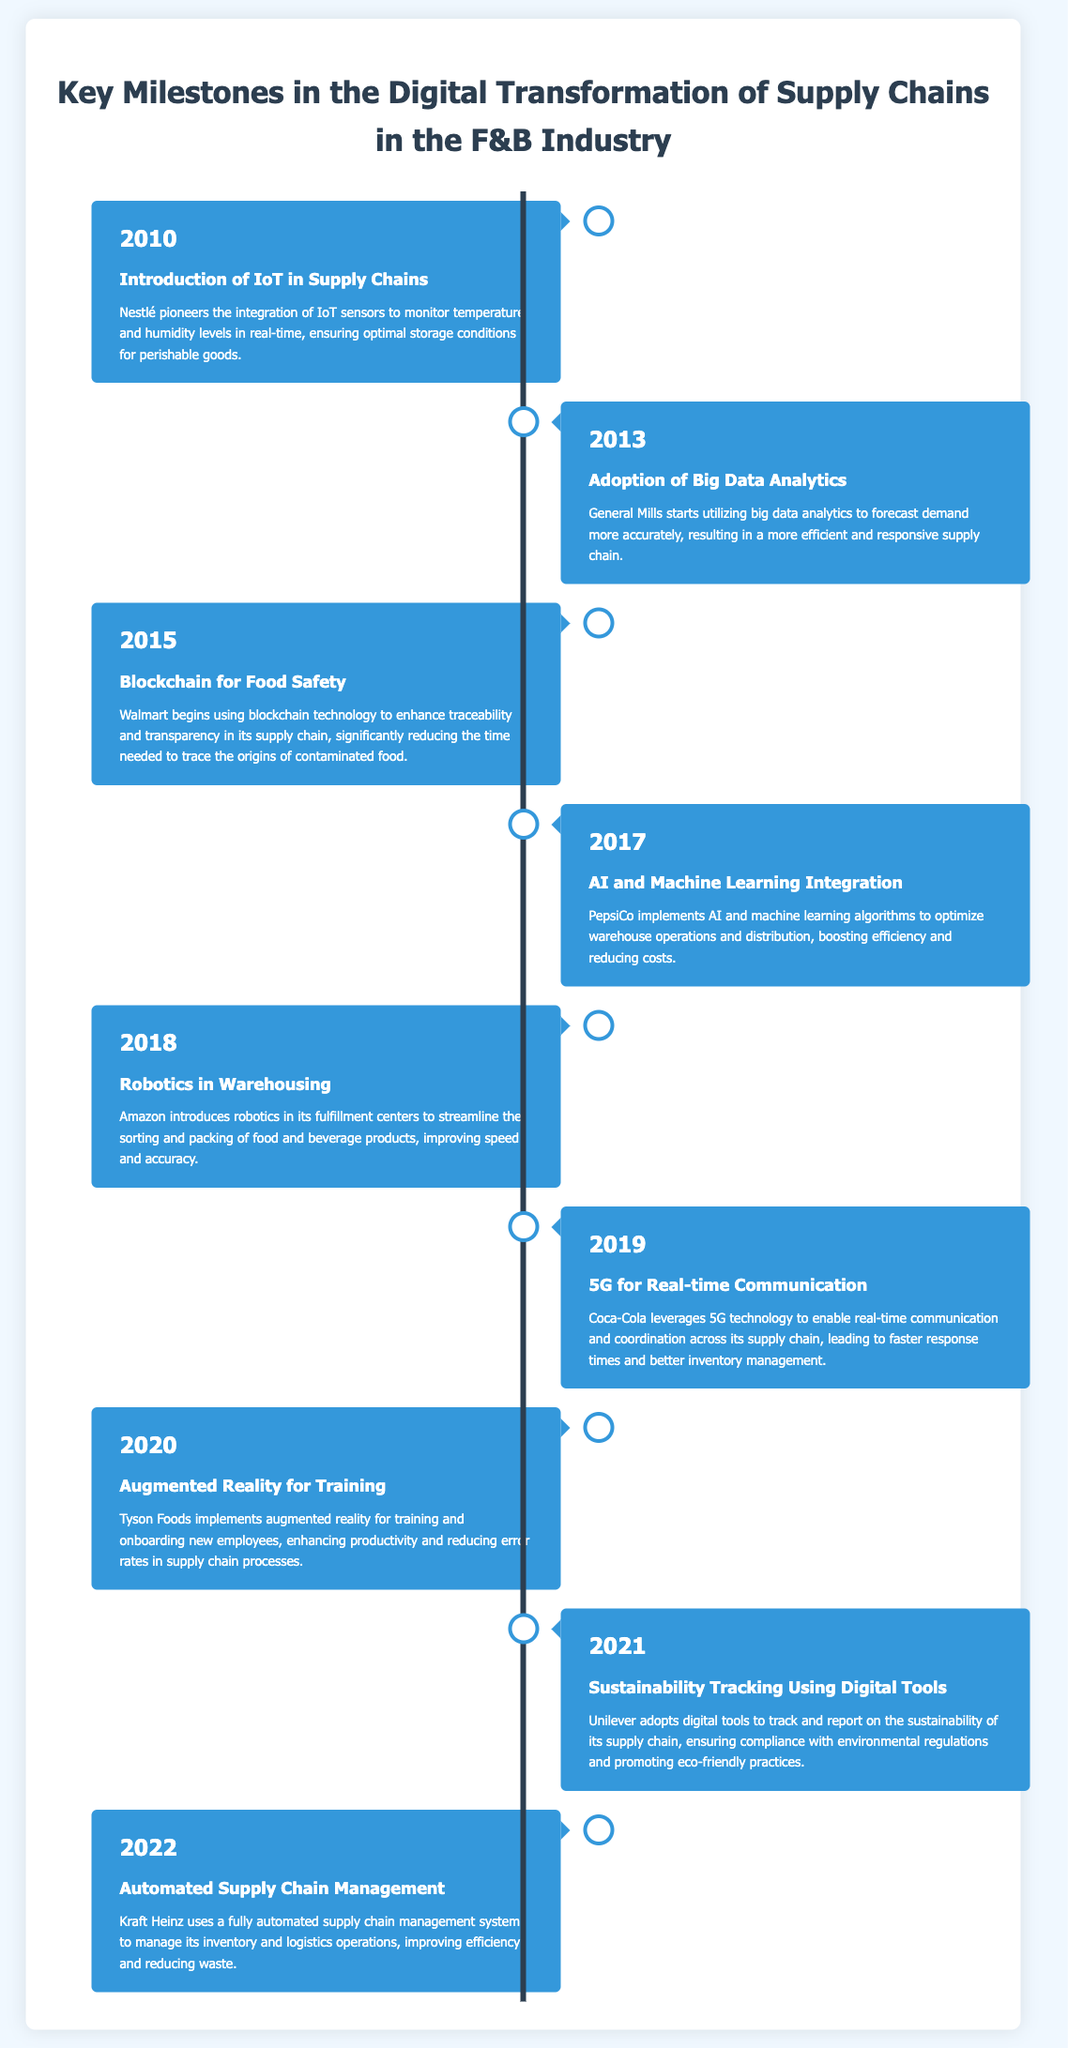What year did Nestlé introduce IoT in supply chains? The document states that Nestlé pioneered the integration of IoT in supply chains in 2010.
Answer: 2010 Which company started utilizing big data analytics in 2013? According to the document, General Mills was the company that started using big data analytics in 2013.
Answer: General Mills What technology did Walmart use in 2015 for food safety? The timeline indicates that Walmart began using blockchain technology for food safety in 2015.
Answer: Blockchain In what year did Coca-Cola leverage 5G technology? The document mentions Coca-Cola leveraging 5G technology in 2019.
Answer: 2019 Which company implemented augmented reality for training in 2020? Tyson Foods is the company that implemented augmented reality for training in 2020, as noted in the document.
Answer: Tyson Foods What is a common trend among the milestones from 2010 to 2022? The milestones show an increasing trend of technological integration within supply chains to enhance efficiency and transparency.
Answer: Technological integration Which technology was introduced by Amazon in 2018? The document states that Amazon introduced robotics in its fulfillment centers in 2018.
Answer: Robotics How many years apart are the milestones between the introduction of IoT and the adoption of big data analytics? The milestones for IoT (2010) and big data analytics (2013) are three years apart.
Answer: 3 years What is the purpose of the sustainability tracking tools adopted by Unilever in 2021? The document explains that these tools help ensure compliance with environmental regulations and promote eco-friendly practices.
Answer: Compliance with environmental regulations 